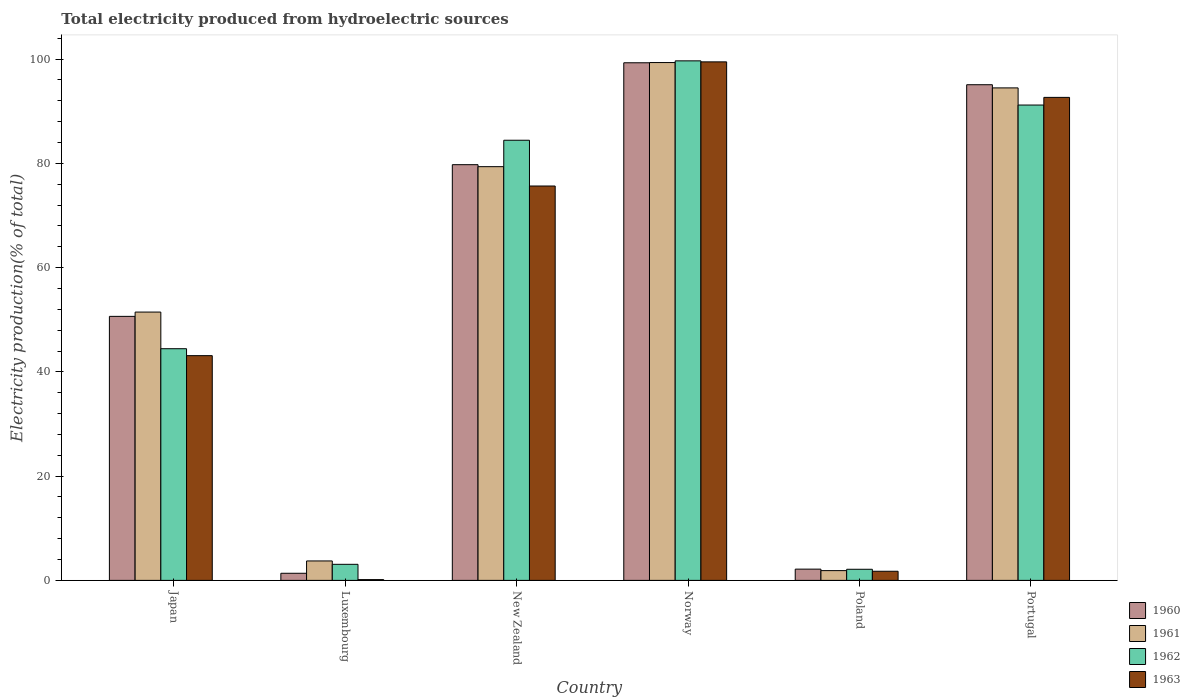How many different coloured bars are there?
Provide a succinct answer. 4. How many groups of bars are there?
Your answer should be compact. 6. Are the number of bars per tick equal to the number of legend labels?
Offer a terse response. Yes. How many bars are there on the 5th tick from the left?
Make the answer very short. 4. How many bars are there on the 4th tick from the right?
Keep it short and to the point. 4. What is the label of the 2nd group of bars from the left?
Give a very brief answer. Luxembourg. What is the total electricity produced in 1961 in New Zealand?
Your answer should be compact. 79.37. Across all countries, what is the maximum total electricity produced in 1961?
Give a very brief answer. 99.34. Across all countries, what is the minimum total electricity produced in 1962?
Provide a short and direct response. 2.13. In which country was the total electricity produced in 1960 minimum?
Your answer should be very brief. Luxembourg. What is the total total electricity produced in 1960 in the graph?
Provide a succinct answer. 328.31. What is the difference between the total electricity produced in 1962 in Luxembourg and that in Norway?
Offer a terse response. -96.59. What is the difference between the total electricity produced in 1962 in Japan and the total electricity produced in 1960 in New Zealand?
Your response must be concise. -35.31. What is the average total electricity produced in 1963 per country?
Ensure brevity in your answer.  52.13. What is the difference between the total electricity produced of/in 1963 and total electricity produced of/in 1961 in New Zealand?
Your answer should be compact. -3.71. What is the ratio of the total electricity produced in 1963 in Poland to that in Portugal?
Give a very brief answer. 0.02. Is the total electricity produced in 1961 in Japan less than that in New Zealand?
Your answer should be very brief. Yes. What is the difference between the highest and the second highest total electricity produced in 1961?
Your response must be concise. 4.86. What is the difference between the highest and the lowest total electricity produced in 1963?
Ensure brevity in your answer.  99.33. Is it the case that in every country, the sum of the total electricity produced in 1963 and total electricity produced in 1960 is greater than the sum of total electricity produced in 1961 and total electricity produced in 1962?
Give a very brief answer. No. What does the 1st bar from the left in Portugal represents?
Make the answer very short. 1960. What does the 2nd bar from the right in Norway represents?
Your response must be concise. 1962. How many bars are there?
Keep it short and to the point. 24. How many countries are there in the graph?
Ensure brevity in your answer.  6. What is the difference between two consecutive major ticks on the Y-axis?
Provide a short and direct response. 20. Does the graph contain grids?
Give a very brief answer. No. How many legend labels are there?
Keep it short and to the point. 4. What is the title of the graph?
Your response must be concise. Total electricity produced from hydroelectric sources. Does "1987" appear as one of the legend labels in the graph?
Offer a terse response. No. What is the Electricity production(% of total) in 1960 in Japan?
Your answer should be compact. 50.65. What is the Electricity production(% of total) in 1961 in Japan?
Give a very brief answer. 51.48. What is the Electricity production(% of total) in 1962 in Japan?
Your answer should be compact. 44.44. What is the Electricity production(% of total) of 1963 in Japan?
Ensure brevity in your answer.  43.11. What is the Electricity production(% of total) of 1960 in Luxembourg?
Offer a very short reply. 1.37. What is the Electricity production(% of total) in 1961 in Luxembourg?
Make the answer very short. 3.73. What is the Electricity production(% of total) in 1962 in Luxembourg?
Make the answer very short. 3.08. What is the Electricity production(% of total) of 1963 in Luxembourg?
Make the answer very short. 0.15. What is the Electricity production(% of total) in 1960 in New Zealand?
Your answer should be compact. 79.75. What is the Electricity production(% of total) of 1961 in New Zealand?
Your response must be concise. 79.37. What is the Electricity production(% of total) of 1962 in New Zealand?
Keep it short and to the point. 84.44. What is the Electricity production(% of total) in 1963 in New Zealand?
Provide a succinct answer. 75.66. What is the Electricity production(% of total) of 1960 in Norway?
Give a very brief answer. 99.3. What is the Electricity production(% of total) of 1961 in Norway?
Provide a succinct answer. 99.34. What is the Electricity production(% of total) of 1962 in Norway?
Your answer should be very brief. 99.67. What is the Electricity production(% of total) of 1963 in Norway?
Offer a terse response. 99.47. What is the Electricity production(% of total) of 1960 in Poland?
Provide a short and direct response. 2.16. What is the Electricity production(% of total) of 1961 in Poland?
Provide a succinct answer. 1.87. What is the Electricity production(% of total) of 1962 in Poland?
Your response must be concise. 2.13. What is the Electricity production(% of total) of 1963 in Poland?
Your response must be concise. 1.75. What is the Electricity production(% of total) of 1960 in Portugal?
Your answer should be compact. 95.09. What is the Electricity production(% of total) in 1961 in Portugal?
Your response must be concise. 94.48. What is the Electricity production(% of total) in 1962 in Portugal?
Your answer should be compact. 91.19. What is the Electricity production(% of total) of 1963 in Portugal?
Your answer should be very brief. 92.66. Across all countries, what is the maximum Electricity production(% of total) in 1960?
Give a very brief answer. 99.3. Across all countries, what is the maximum Electricity production(% of total) of 1961?
Make the answer very short. 99.34. Across all countries, what is the maximum Electricity production(% of total) of 1962?
Your response must be concise. 99.67. Across all countries, what is the maximum Electricity production(% of total) of 1963?
Keep it short and to the point. 99.47. Across all countries, what is the minimum Electricity production(% of total) of 1960?
Keep it short and to the point. 1.37. Across all countries, what is the minimum Electricity production(% of total) in 1961?
Provide a short and direct response. 1.87. Across all countries, what is the minimum Electricity production(% of total) of 1962?
Provide a short and direct response. 2.13. Across all countries, what is the minimum Electricity production(% of total) of 1963?
Offer a terse response. 0.15. What is the total Electricity production(% of total) of 1960 in the graph?
Provide a short and direct response. 328.31. What is the total Electricity production(% of total) of 1961 in the graph?
Ensure brevity in your answer.  330.28. What is the total Electricity production(% of total) of 1962 in the graph?
Your answer should be very brief. 324.96. What is the total Electricity production(% of total) in 1963 in the graph?
Ensure brevity in your answer.  312.81. What is the difference between the Electricity production(% of total) of 1960 in Japan and that in Luxembourg?
Your answer should be very brief. 49.28. What is the difference between the Electricity production(% of total) of 1961 in Japan and that in Luxembourg?
Your response must be concise. 47.75. What is the difference between the Electricity production(% of total) of 1962 in Japan and that in Luxembourg?
Provide a short and direct response. 41.36. What is the difference between the Electricity production(% of total) of 1963 in Japan and that in Luxembourg?
Provide a succinct answer. 42.97. What is the difference between the Electricity production(% of total) of 1960 in Japan and that in New Zealand?
Your answer should be compact. -29.1. What is the difference between the Electricity production(% of total) of 1961 in Japan and that in New Zealand?
Offer a terse response. -27.9. What is the difference between the Electricity production(% of total) of 1962 in Japan and that in New Zealand?
Make the answer very short. -39.99. What is the difference between the Electricity production(% of total) of 1963 in Japan and that in New Zealand?
Your answer should be very brief. -32.54. What is the difference between the Electricity production(% of total) of 1960 in Japan and that in Norway?
Your answer should be compact. -48.65. What is the difference between the Electricity production(% of total) of 1961 in Japan and that in Norway?
Give a very brief answer. -47.87. What is the difference between the Electricity production(% of total) of 1962 in Japan and that in Norway?
Keep it short and to the point. -55.23. What is the difference between the Electricity production(% of total) in 1963 in Japan and that in Norway?
Provide a short and direct response. -56.36. What is the difference between the Electricity production(% of total) in 1960 in Japan and that in Poland?
Offer a terse response. 48.49. What is the difference between the Electricity production(% of total) in 1961 in Japan and that in Poland?
Give a very brief answer. 49.6. What is the difference between the Electricity production(% of total) of 1962 in Japan and that in Poland?
Offer a terse response. 42.31. What is the difference between the Electricity production(% of total) of 1963 in Japan and that in Poland?
Offer a very short reply. 41.36. What is the difference between the Electricity production(% of total) in 1960 in Japan and that in Portugal?
Your answer should be compact. -44.44. What is the difference between the Electricity production(% of total) of 1961 in Japan and that in Portugal?
Make the answer very short. -43. What is the difference between the Electricity production(% of total) of 1962 in Japan and that in Portugal?
Provide a succinct answer. -46.75. What is the difference between the Electricity production(% of total) of 1963 in Japan and that in Portugal?
Ensure brevity in your answer.  -49.55. What is the difference between the Electricity production(% of total) in 1960 in Luxembourg and that in New Zealand?
Keep it short and to the point. -78.38. What is the difference between the Electricity production(% of total) of 1961 in Luxembourg and that in New Zealand?
Keep it short and to the point. -75.64. What is the difference between the Electricity production(% of total) of 1962 in Luxembourg and that in New Zealand?
Your answer should be very brief. -81.36. What is the difference between the Electricity production(% of total) in 1963 in Luxembourg and that in New Zealand?
Make the answer very short. -75.51. What is the difference between the Electricity production(% of total) in 1960 in Luxembourg and that in Norway?
Your response must be concise. -97.93. What is the difference between the Electricity production(% of total) in 1961 in Luxembourg and that in Norway?
Your response must be concise. -95.61. What is the difference between the Electricity production(% of total) of 1962 in Luxembourg and that in Norway?
Make the answer very short. -96.59. What is the difference between the Electricity production(% of total) of 1963 in Luxembourg and that in Norway?
Your answer should be compact. -99.33. What is the difference between the Electricity production(% of total) in 1960 in Luxembourg and that in Poland?
Your answer should be compact. -0.79. What is the difference between the Electricity production(% of total) in 1961 in Luxembourg and that in Poland?
Your answer should be compact. 1.86. What is the difference between the Electricity production(% of total) in 1962 in Luxembourg and that in Poland?
Keep it short and to the point. 0.95. What is the difference between the Electricity production(% of total) in 1963 in Luxembourg and that in Poland?
Your answer should be very brief. -1.6. What is the difference between the Electricity production(% of total) of 1960 in Luxembourg and that in Portugal?
Your response must be concise. -93.72. What is the difference between the Electricity production(% of total) of 1961 in Luxembourg and that in Portugal?
Offer a terse response. -90.75. What is the difference between the Electricity production(% of total) of 1962 in Luxembourg and that in Portugal?
Your answer should be very brief. -88.11. What is the difference between the Electricity production(% of total) of 1963 in Luxembourg and that in Portugal?
Your response must be concise. -92.51. What is the difference between the Electricity production(% of total) of 1960 in New Zealand and that in Norway?
Ensure brevity in your answer.  -19.55. What is the difference between the Electricity production(% of total) in 1961 in New Zealand and that in Norway?
Keep it short and to the point. -19.97. What is the difference between the Electricity production(% of total) in 1962 in New Zealand and that in Norway?
Give a very brief answer. -15.23. What is the difference between the Electricity production(% of total) in 1963 in New Zealand and that in Norway?
Provide a succinct answer. -23.82. What is the difference between the Electricity production(% of total) of 1960 in New Zealand and that in Poland?
Provide a succinct answer. 77.59. What is the difference between the Electricity production(% of total) of 1961 in New Zealand and that in Poland?
Your answer should be compact. 77.5. What is the difference between the Electricity production(% of total) of 1962 in New Zealand and that in Poland?
Provide a short and direct response. 82.31. What is the difference between the Electricity production(% of total) in 1963 in New Zealand and that in Poland?
Provide a short and direct response. 73.91. What is the difference between the Electricity production(% of total) of 1960 in New Zealand and that in Portugal?
Offer a very short reply. -15.34. What is the difference between the Electricity production(% of total) in 1961 in New Zealand and that in Portugal?
Keep it short and to the point. -15.11. What is the difference between the Electricity production(% of total) of 1962 in New Zealand and that in Portugal?
Give a very brief answer. -6.75. What is the difference between the Electricity production(% of total) in 1963 in New Zealand and that in Portugal?
Offer a terse response. -17. What is the difference between the Electricity production(% of total) in 1960 in Norway and that in Poland?
Make the answer very short. 97.14. What is the difference between the Electricity production(% of total) of 1961 in Norway and that in Poland?
Give a very brief answer. 97.47. What is the difference between the Electricity production(% of total) in 1962 in Norway and that in Poland?
Ensure brevity in your answer.  97.54. What is the difference between the Electricity production(% of total) of 1963 in Norway and that in Poland?
Provide a succinct answer. 97.72. What is the difference between the Electricity production(% of total) of 1960 in Norway and that in Portugal?
Your answer should be compact. 4.21. What is the difference between the Electricity production(% of total) of 1961 in Norway and that in Portugal?
Ensure brevity in your answer.  4.86. What is the difference between the Electricity production(% of total) in 1962 in Norway and that in Portugal?
Provide a short and direct response. 8.48. What is the difference between the Electricity production(% of total) in 1963 in Norway and that in Portugal?
Offer a very short reply. 6.81. What is the difference between the Electricity production(% of total) in 1960 in Poland and that in Portugal?
Give a very brief answer. -92.93. What is the difference between the Electricity production(% of total) in 1961 in Poland and that in Portugal?
Provide a succinct answer. -92.61. What is the difference between the Electricity production(% of total) in 1962 in Poland and that in Portugal?
Provide a succinct answer. -89.06. What is the difference between the Electricity production(% of total) of 1963 in Poland and that in Portugal?
Provide a short and direct response. -90.91. What is the difference between the Electricity production(% of total) in 1960 in Japan and the Electricity production(% of total) in 1961 in Luxembourg?
Offer a terse response. 46.92. What is the difference between the Electricity production(% of total) in 1960 in Japan and the Electricity production(% of total) in 1962 in Luxembourg?
Your answer should be very brief. 47.57. What is the difference between the Electricity production(% of total) of 1960 in Japan and the Electricity production(% of total) of 1963 in Luxembourg?
Offer a very short reply. 50.5. What is the difference between the Electricity production(% of total) in 1961 in Japan and the Electricity production(% of total) in 1962 in Luxembourg?
Ensure brevity in your answer.  48.39. What is the difference between the Electricity production(% of total) in 1961 in Japan and the Electricity production(% of total) in 1963 in Luxembourg?
Provide a succinct answer. 51.33. What is the difference between the Electricity production(% of total) in 1962 in Japan and the Electricity production(% of total) in 1963 in Luxembourg?
Provide a short and direct response. 44.3. What is the difference between the Electricity production(% of total) of 1960 in Japan and the Electricity production(% of total) of 1961 in New Zealand?
Ensure brevity in your answer.  -28.72. What is the difference between the Electricity production(% of total) of 1960 in Japan and the Electricity production(% of total) of 1962 in New Zealand?
Keep it short and to the point. -33.79. What is the difference between the Electricity production(% of total) of 1960 in Japan and the Electricity production(% of total) of 1963 in New Zealand?
Ensure brevity in your answer.  -25.01. What is the difference between the Electricity production(% of total) of 1961 in Japan and the Electricity production(% of total) of 1962 in New Zealand?
Your answer should be very brief. -32.96. What is the difference between the Electricity production(% of total) of 1961 in Japan and the Electricity production(% of total) of 1963 in New Zealand?
Offer a very short reply. -24.18. What is the difference between the Electricity production(% of total) of 1962 in Japan and the Electricity production(% of total) of 1963 in New Zealand?
Offer a very short reply. -31.21. What is the difference between the Electricity production(% of total) of 1960 in Japan and the Electricity production(% of total) of 1961 in Norway?
Your answer should be compact. -48.69. What is the difference between the Electricity production(% of total) in 1960 in Japan and the Electricity production(% of total) in 1962 in Norway?
Offer a very short reply. -49.02. What is the difference between the Electricity production(% of total) of 1960 in Japan and the Electricity production(% of total) of 1963 in Norway?
Provide a short and direct response. -48.83. What is the difference between the Electricity production(% of total) in 1961 in Japan and the Electricity production(% of total) in 1962 in Norway?
Give a very brief answer. -48.19. What is the difference between the Electricity production(% of total) of 1961 in Japan and the Electricity production(% of total) of 1963 in Norway?
Provide a succinct answer. -48. What is the difference between the Electricity production(% of total) in 1962 in Japan and the Electricity production(% of total) in 1963 in Norway?
Your response must be concise. -55.03. What is the difference between the Electricity production(% of total) of 1960 in Japan and the Electricity production(% of total) of 1961 in Poland?
Offer a terse response. 48.78. What is the difference between the Electricity production(% of total) of 1960 in Japan and the Electricity production(% of total) of 1962 in Poland?
Ensure brevity in your answer.  48.52. What is the difference between the Electricity production(% of total) of 1960 in Japan and the Electricity production(% of total) of 1963 in Poland?
Give a very brief answer. 48.9. What is the difference between the Electricity production(% of total) of 1961 in Japan and the Electricity production(% of total) of 1962 in Poland?
Provide a short and direct response. 49.34. What is the difference between the Electricity production(% of total) in 1961 in Japan and the Electricity production(% of total) in 1963 in Poland?
Provide a succinct answer. 49.72. What is the difference between the Electricity production(% of total) of 1962 in Japan and the Electricity production(% of total) of 1963 in Poland?
Give a very brief answer. 42.69. What is the difference between the Electricity production(% of total) in 1960 in Japan and the Electricity production(% of total) in 1961 in Portugal?
Give a very brief answer. -43.83. What is the difference between the Electricity production(% of total) in 1960 in Japan and the Electricity production(% of total) in 1962 in Portugal?
Provide a succinct answer. -40.54. What is the difference between the Electricity production(% of total) in 1960 in Japan and the Electricity production(% of total) in 1963 in Portugal?
Give a very brief answer. -42.01. What is the difference between the Electricity production(% of total) in 1961 in Japan and the Electricity production(% of total) in 1962 in Portugal?
Make the answer very short. -39.72. What is the difference between the Electricity production(% of total) in 1961 in Japan and the Electricity production(% of total) in 1963 in Portugal?
Your answer should be very brief. -41.18. What is the difference between the Electricity production(% of total) of 1962 in Japan and the Electricity production(% of total) of 1963 in Portugal?
Provide a short and direct response. -48.22. What is the difference between the Electricity production(% of total) in 1960 in Luxembourg and the Electricity production(% of total) in 1961 in New Zealand?
Give a very brief answer. -78.01. What is the difference between the Electricity production(% of total) of 1960 in Luxembourg and the Electricity production(% of total) of 1962 in New Zealand?
Offer a terse response. -83.07. What is the difference between the Electricity production(% of total) of 1960 in Luxembourg and the Electricity production(% of total) of 1963 in New Zealand?
Provide a succinct answer. -74.29. What is the difference between the Electricity production(% of total) in 1961 in Luxembourg and the Electricity production(% of total) in 1962 in New Zealand?
Provide a short and direct response. -80.71. What is the difference between the Electricity production(% of total) of 1961 in Luxembourg and the Electricity production(% of total) of 1963 in New Zealand?
Provide a short and direct response. -71.93. What is the difference between the Electricity production(% of total) of 1962 in Luxembourg and the Electricity production(% of total) of 1963 in New Zealand?
Your answer should be compact. -72.58. What is the difference between the Electricity production(% of total) in 1960 in Luxembourg and the Electricity production(% of total) in 1961 in Norway?
Your answer should be compact. -97.98. What is the difference between the Electricity production(% of total) of 1960 in Luxembourg and the Electricity production(% of total) of 1962 in Norway?
Make the answer very short. -98.3. What is the difference between the Electricity production(% of total) of 1960 in Luxembourg and the Electricity production(% of total) of 1963 in Norway?
Offer a terse response. -98.11. What is the difference between the Electricity production(% of total) in 1961 in Luxembourg and the Electricity production(% of total) in 1962 in Norway?
Provide a succinct answer. -95.94. What is the difference between the Electricity production(% of total) of 1961 in Luxembourg and the Electricity production(% of total) of 1963 in Norway?
Keep it short and to the point. -95.74. What is the difference between the Electricity production(% of total) of 1962 in Luxembourg and the Electricity production(% of total) of 1963 in Norway?
Provide a succinct answer. -96.39. What is the difference between the Electricity production(% of total) of 1960 in Luxembourg and the Electricity production(% of total) of 1961 in Poland?
Your response must be concise. -0.51. What is the difference between the Electricity production(% of total) of 1960 in Luxembourg and the Electricity production(% of total) of 1962 in Poland?
Offer a terse response. -0.77. What is the difference between the Electricity production(% of total) in 1960 in Luxembourg and the Electricity production(% of total) in 1963 in Poland?
Provide a succinct answer. -0.39. What is the difference between the Electricity production(% of total) of 1961 in Luxembourg and the Electricity production(% of total) of 1962 in Poland?
Offer a very short reply. 1.6. What is the difference between the Electricity production(% of total) of 1961 in Luxembourg and the Electricity production(% of total) of 1963 in Poland?
Keep it short and to the point. 1.98. What is the difference between the Electricity production(% of total) of 1962 in Luxembourg and the Electricity production(% of total) of 1963 in Poland?
Provide a short and direct response. 1.33. What is the difference between the Electricity production(% of total) of 1960 in Luxembourg and the Electricity production(% of total) of 1961 in Portugal?
Provide a short and direct response. -93.11. What is the difference between the Electricity production(% of total) of 1960 in Luxembourg and the Electricity production(% of total) of 1962 in Portugal?
Provide a short and direct response. -89.83. What is the difference between the Electricity production(% of total) in 1960 in Luxembourg and the Electricity production(% of total) in 1963 in Portugal?
Offer a very short reply. -91.29. What is the difference between the Electricity production(% of total) of 1961 in Luxembourg and the Electricity production(% of total) of 1962 in Portugal?
Your response must be concise. -87.46. What is the difference between the Electricity production(% of total) of 1961 in Luxembourg and the Electricity production(% of total) of 1963 in Portugal?
Ensure brevity in your answer.  -88.93. What is the difference between the Electricity production(% of total) in 1962 in Luxembourg and the Electricity production(% of total) in 1963 in Portugal?
Your answer should be compact. -89.58. What is the difference between the Electricity production(% of total) of 1960 in New Zealand and the Electricity production(% of total) of 1961 in Norway?
Your answer should be very brief. -19.59. What is the difference between the Electricity production(% of total) in 1960 in New Zealand and the Electricity production(% of total) in 1962 in Norway?
Give a very brief answer. -19.92. What is the difference between the Electricity production(% of total) in 1960 in New Zealand and the Electricity production(% of total) in 1963 in Norway?
Offer a terse response. -19.72. What is the difference between the Electricity production(% of total) of 1961 in New Zealand and the Electricity production(% of total) of 1962 in Norway?
Give a very brief answer. -20.3. What is the difference between the Electricity production(% of total) of 1961 in New Zealand and the Electricity production(% of total) of 1963 in Norway?
Provide a succinct answer. -20.1. What is the difference between the Electricity production(% of total) in 1962 in New Zealand and the Electricity production(% of total) in 1963 in Norway?
Provide a short and direct response. -15.04. What is the difference between the Electricity production(% of total) of 1960 in New Zealand and the Electricity production(% of total) of 1961 in Poland?
Provide a short and direct response. 77.88. What is the difference between the Electricity production(% of total) of 1960 in New Zealand and the Electricity production(% of total) of 1962 in Poland?
Give a very brief answer. 77.62. What is the difference between the Electricity production(% of total) in 1960 in New Zealand and the Electricity production(% of total) in 1963 in Poland?
Offer a terse response. 78. What is the difference between the Electricity production(% of total) of 1961 in New Zealand and the Electricity production(% of total) of 1962 in Poland?
Make the answer very short. 77.24. What is the difference between the Electricity production(% of total) of 1961 in New Zealand and the Electricity production(% of total) of 1963 in Poland?
Offer a very short reply. 77.62. What is the difference between the Electricity production(% of total) in 1962 in New Zealand and the Electricity production(% of total) in 1963 in Poland?
Your answer should be compact. 82.69. What is the difference between the Electricity production(% of total) of 1960 in New Zealand and the Electricity production(% of total) of 1961 in Portugal?
Your answer should be very brief. -14.73. What is the difference between the Electricity production(% of total) in 1960 in New Zealand and the Electricity production(% of total) in 1962 in Portugal?
Your answer should be compact. -11.44. What is the difference between the Electricity production(% of total) in 1960 in New Zealand and the Electricity production(% of total) in 1963 in Portugal?
Your response must be concise. -12.91. What is the difference between the Electricity production(% of total) of 1961 in New Zealand and the Electricity production(% of total) of 1962 in Portugal?
Provide a succinct answer. -11.82. What is the difference between the Electricity production(% of total) in 1961 in New Zealand and the Electricity production(% of total) in 1963 in Portugal?
Your response must be concise. -13.29. What is the difference between the Electricity production(% of total) of 1962 in New Zealand and the Electricity production(% of total) of 1963 in Portugal?
Keep it short and to the point. -8.22. What is the difference between the Electricity production(% of total) of 1960 in Norway and the Electricity production(% of total) of 1961 in Poland?
Your response must be concise. 97.43. What is the difference between the Electricity production(% of total) in 1960 in Norway and the Electricity production(% of total) in 1962 in Poland?
Give a very brief answer. 97.17. What is the difference between the Electricity production(% of total) of 1960 in Norway and the Electricity production(% of total) of 1963 in Poland?
Offer a terse response. 97.55. What is the difference between the Electricity production(% of total) of 1961 in Norway and the Electricity production(% of total) of 1962 in Poland?
Offer a terse response. 97.21. What is the difference between the Electricity production(% of total) in 1961 in Norway and the Electricity production(% of total) in 1963 in Poland?
Offer a terse response. 97.59. What is the difference between the Electricity production(% of total) in 1962 in Norway and the Electricity production(% of total) in 1963 in Poland?
Keep it short and to the point. 97.92. What is the difference between the Electricity production(% of total) of 1960 in Norway and the Electricity production(% of total) of 1961 in Portugal?
Keep it short and to the point. 4.82. What is the difference between the Electricity production(% of total) in 1960 in Norway and the Electricity production(% of total) in 1962 in Portugal?
Your answer should be compact. 8.11. What is the difference between the Electricity production(% of total) in 1960 in Norway and the Electricity production(% of total) in 1963 in Portugal?
Make the answer very short. 6.64. What is the difference between the Electricity production(% of total) in 1961 in Norway and the Electricity production(% of total) in 1962 in Portugal?
Offer a terse response. 8.15. What is the difference between the Electricity production(% of total) in 1961 in Norway and the Electricity production(% of total) in 1963 in Portugal?
Give a very brief answer. 6.68. What is the difference between the Electricity production(% of total) of 1962 in Norway and the Electricity production(% of total) of 1963 in Portugal?
Offer a very short reply. 7.01. What is the difference between the Electricity production(% of total) of 1960 in Poland and the Electricity production(% of total) of 1961 in Portugal?
Your response must be concise. -92.32. What is the difference between the Electricity production(% of total) in 1960 in Poland and the Electricity production(% of total) in 1962 in Portugal?
Keep it short and to the point. -89.03. What is the difference between the Electricity production(% of total) of 1960 in Poland and the Electricity production(% of total) of 1963 in Portugal?
Provide a short and direct response. -90.5. What is the difference between the Electricity production(% of total) of 1961 in Poland and the Electricity production(% of total) of 1962 in Portugal?
Give a very brief answer. -89.32. What is the difference between the Electricity production(% of total) in 1961 in Poland and the Electricity production(% of total) in 1963 in Portugal?
Your answer should be compact. -90.79. What is the difference between the Electricity production(% of total) in 1962 in Poland and the Electricity production(% of total) in 1963 in Portugal?
Make the answer very short. -90.53. What is the average Electricity production(% of total) in 1960 per country?
Your response must be concise. 54.72. What is the average Electricity production(% of total) of 1961 per country?
Make the answer very short. 55.05. What is the average Electricity production(% of total) in 1962 per country?
Give a very brief answer. 54.16. What is the average Electricity production(% of total) of 1963 per country?
Your answer should be compact. 52.13. What is the difference between the Electricity production(% of total) in 1960 and Electricity production(% of total) in 1961 in Japan?
Provide a succinct answer. -0.83. What is the difference between the Electricity production(% of total) in 1960 and Electricity production(% of total) in 1962 in Japan?
Your response must be concise. 6.2. What is the difference between the Electricity production(% of total) of 1960 and Electricity production(% of total) of 1963 in Japan?
Make the answer very short. 7.54. What is the difference between the Electricity production(% of total) in 1961 and Electricity production(% of total) in 1962 in Japan?
Give a very brief answer. 7.03. What is the difference between the Electricity production(% of total) in 1961 and Electricity production(% of total) in 1963 in Japan?
Give a very brief answer. 8.36. What is the difference between the Electricity production(% of total) of 1962 and Electricity production(% of total) of 1963 in Japan?
Offer a terse response. 1.33. What is the difference between the Electricity production(% of total) in 1960 and Electricity production(% of total) in 1961 in Luxembourg?
Offer a very short reply. -2.36. What is the difference between the Electricity production(% of total) of 1960 and Electricity production(% of total) of 1962 in Luxembourg?
Your response must be concise. -1.72. What is the difference between the Electricity production(% of total) in 1960 and Electricity production(% of total) in 1963 in Luxembourg?
Offer a terse response. 1.22. What is the difference between the Electricity production(% of total) in 1961 and Electricity production(% of total) in 1962 in Luxembourg?
Make the answer very short. 0.65. What is the difference between the Electricity production(% of total) in 1961 and Electricity production(% of total) in 1963 in Luxembourg?
Ensure brevity in your answer.  3.58. What is the difference between the Electricity production(% of total) of 1962 and Electricity production(% of total) of 1963 in Luxembourg?
Make the answer very short. 2.93. What is the difference between the Electricity production(% of total) of 1960 and Electricity production(% of total) of 1961 in New Zealand?
Provide a succinct answer. 0.38. What is the difference between the Electricity production(% of total) in 1960 and Electricity production(% of total) in 1962 in New Zealand?
Your answer should be very brief. -4.69. What is the difference between the Electricity production(% of total) in 1960 and Electricity production(% of total) in 1963 in New Zealand?
Make the answer very short. 4.09. What is the difference between the Electricity production(% of total) of 1961 and Electricity production(% of total) of 1962 in New Zealand?
Offer a terse response. -5.07. What is the difference between the Electricity production(% of total) of 1961 and Electricity production(% of total) of 1963 in New Zealand?
Provide a succinct answer. 3.71. What is the difference between the Electricity production(% of total) of 1962 and Electricity production(% of total) of 1963 in New Zealand?
Make the answer very short. 8.78. What is the difference between the Electricity production(% of total) of 1960 and Electricity production(% of total) of 1961 in Norway?
Make the answer very short. -0.04. What is the difference between the Electricity production(% of total) in 1960 and Electricity production(% of total) in 1962 in Norway?
Provide a short and direct response. -0.37. What is the difference between the Electricity production(% of total) of 1960 and Electricity production(% of total) of 1963 in Norway?
Your answer should be very brief. -0.17. What is the difference between the Electricity production(% of total) of 1961 and Electricity production(% of total) of 1962 in Norway?
Your response must be concise. -0.33. What is the difference between the Electricity production(% of total) in 1961 and Electricity production(% of total) in 1963 in Norway?
Give a very brief answer. -0.13. What is the difference between the Electricity production(% of total) of 1962 and Electricity production(% of total) of 1963 in Norway?
Make the answer very short. 0.19. What is the difference between the Electricity production(% of total) of 1960 and Electricity production(% of total) of 1961 in Poland?
Make the answer very short. 0.28. What is the difference between the Electricity production(% of total) of 1960 and Electricity production(% of total) of 1962 in Poland?
Offer a very short reply. 0.03. What is the difference between the Electricity production(% of total) of 1960 and Electricity production(% of total) of 1963 in Poland?
Provide a short and direct response. 0.41. What is the difference between the Electricity production(% of total) of 1961 and Electricity production(% of total) of 1962 in Poland?
Keep it short and to the point. -0.26. What is the difference between the Electricity production(% of total) in 1961 and Electricity production(% of total) in 1963 in Poland?
Your answer should be very brief. 0.12. What is the difference between the Electricity production(% of total) of 1962 and Electricity production(% of total) of 1963 in Poland?
Offer a very short reply. 0.38. What is the difference between the Electricity production(% of total) in 1960 and Electricity production(% of total) in 1961 in Portugal?
Offer a terse response. 0.61. What is the difference between the Electricity production(% of total) in 1960 and Electricity production(% of total) in 1962 in Portugal?
Provide a short and direct response. 3.9. What is the difference between the Electricity production(% of total) in 1960 and Electricity production(% of total) in 1963 in Portugal?
Give a very brief answer. 2.43. What is the difference between the Electricity production(% of total) of 1961 and Electricity production(% of total) of 1962 in Portugal?
Give a very brief answer. 3.29. What is the difference between the Electricity production(% of total) in 1961 and Electricity production(% of total) in 1963 in Portugal?
Provide a short and direct response. 1.82. What is the difference between the Electricity production(% of total) of 1962 and Electricity production(% of total) of 1963 in Portugal?
Keep it short and to the point. -1.47. What is the ratio of the Electricity production(% of total) of 1960 in Japan to that in Luxembourg?
Provide a succinct answer. 37.08. What is the ratio of the Electricity production(% of total) in 1961 in Japan to that in Luxembourg?
Offer a terse response. 13.8. What is the ratio of the Electricity production(% of total) of 1962 in Japan to that in Luxembourg?
Give a very brief answer. 14.42. What is the ratio of the Electricity production(% of total) in 1963 in Japan to that in Luxembourg?
Your response must be concise. 292.1. What is the ratio of the Electricity production(% of total) in 1960 in Japan to that in New Zealand?
Your answer should be compact. 0.64. What is the ratio of the Electricity production(% of total) in 1961 in Japan to that in New Zealand?
Your response must be concise. 0.65. What is the ratio of the Electricity production(% of total) of 1962 in Japan to that in New Zealand?
Keep it short and to the point. 0.53. What is the ratio of the Electricity production(% of total) of 1963 in Japan to that in New Zealand?
Keep it short and to the point. 0.57. What is the ratio of the Electricity production(% of total) in 1960 in Japan to that in Norway?
Your response must be concise. 0.51. What is the ratio of the Electricity production(% of total) of 1961 in Japan to that in Norway?
Offer a terse response. 0.52. What is the ratio of the Electricity production(% of total) of 1962 in Japan to that in Norway?
Make the answer very short. 0.45. What is the ratio of the Electricity production(% of total) in 1963 in Japan to that in Norway?
Your answer should be compact. 0.43. What is the ratio of the Electricity production(% of total) in 1960 in Japan to that in Poland?
Keep it short and to the point. 23.47. What is the ratio of the Electricity production(% of total) in 1961 in Japan to that in Poland?
Make the answer very short. 27.48. What is the ratio of the Electricity production(% of total) in 1962 in Japan to that in Poland?
Your response must be concise. 20.85. What is the ratio of the Electricity production(% of total) in 1963 in Japan to that in Poland?
Provide a short and direct response. 24.62. What is the ratio of the Electricity production(% of total) in 1960 in Japan to that in Portugal?
Your answer should be compact. 0.53. What is the ratio of the Electricity production(% of total) in 1961 in Japan to that in Portugal?
Give a very brief answer. 0.54. What is the ratio of the Electricity production(% of total) in 1962 in Japan to that in Portugal?
Provide a short and direct response. 0.49. What is the ratio of the Electricity production(% of total) of 1963 in Japan to that in Portugal?
Ensure brevity in your answer.  0.47. What is the ratio of the Electricity production(% of total) of 1960 in Luxembourg to that in New Zealand?
Offer a terse response. 0.02. What is the ratio of the Electricity production(% of total) in 1961 in Luxembourg to that in New Zealand?
Your answer should be very brief. 0.05. What is the ratio of the Electricity production(% of total) in 1962 in Luxembourg to that in New Zealand?
Offer a terse response. 0.04. What is the ratio of the Electricity production(% of total) of 1963 in Luxembourg to that in New Zealand?
Your answer should be very brief. 0. What is the ratio of the Electricity production(% of total) in 1960 in Luxembourg to that in Norway?
Offer a very short reply. 0.01. What is the ratio of the Electricity production(% of total) in 1961 in Luxembourg to that in Norway?
Provide a short and direct response. 0.04. What is the ratio of the Electricity production(% of total) of 1962 in Luxembourg to that in Norway?
Your response must be concise. 0.03. What is the ratio of the Electricity production(% of total) in 1963 in Luxembourg to that in Norway?
Offer a very short reply. 0. What is the ratio of the Electricity production(% of total) in 1960 in Luxembourg to that in Poland?
Your answer should be very brief. 0.63. What is the ratio of the Electricity production(% of total) in 1961 in Luxembourg to that in Poland?
Your answer should be very brief. 1.99. What is the ratio of the Electricity production(% of total) in 1962 in Luxembourg to that in Poland?
Offer a terse response. 1.45. What is the ratio of the Electricity production(% of total) in 1963 in Luxembourg to that in Poland?
Offer a very short reply. 0.08. What is the ratio of the Electricity production(% of total) in 1960 in Luxembourg to that in Portugal?
Your answer should be compact. 0.01. What is the ratio of the Electricity production(% of total) in 1961 in Luxembourg to that in Portugal?
Offer a very short reply. 0.04. What is the ratio of the Electricity production(% of total) of 1962 in Luxembourg to that in Portugal?
Your answer should be compact. 0.03. What is the ratio of the Electricity production(% of total) of 1963 in Luxembourg to that in Portugal?
Your response must be concise. 0. What is the ratio of the Electricity production(% of total) in 1960 in New Zealand to that in Norway?
Ensure brevity in your answer.  0.8. What is the ratio of the Electricity production(% of total) in 1961 in New Zealand to that in Norway?
Offer a very short reply. 0.8. What is the ratio of the Electricity production(% of total) of 1962 in New Zealand to that in Norway?
Give a very brief answer. 0.85. What is the ratio of the Electricity production(% of total) of 1963 in New Zealand to that in Norway?
Ensure brevity in your answer.  0.76. What is the ratio of the Electricity production(% of total) of 1960 in New Zealand to that in Poland?
Offer a terse response. 36.95. What is the ratio of the Electricity production(% of total) in 1961 in New Zealand to that in Poland?
Provide a short and direct response. 42.37. What is the ratio of the Electricity production(% of total) in 1962 in New Zealand to that in Poland?
Your response must be concise. 39.6. What is the ratio of the Electricity production(% of total) of 1963 in New Zealand to that in Poland?
Offer a very short reply. 43.2. What is the ratio of the Electricity production(% of total) in 1960 in New Zealand to that in Portugal?
Provide a short and direct response. 0.84. What is the ratio of the Electricity production(% of total) of 1961 in New Zealand to that in Portugal?
Your response must be concise. 0.84. What is the ratio of the Electricity production(% of total) of 1962 in New Zealand to that in Portugal?
Provide a succinct answer. 0.93. What is the ratio of the Electricity production(% of total) in 1963 in New Zealand to that in Portugal?
Your answer should be compact. 0.82. What is the ratio of the Electricity production(% of total) in 1960 in Norway to that in Poland?
Keep it short and to the point. 46.01. What is the ratio of the Electricity production(% of total) in 1961 in Norway to that in Poland?
Provide a short and direct response. 53.03. What is the ratio of the Electricity production(% of total) in 1962 in Norway to that in Poland?
Your answer should be very brief. 46.75. What is the ratio of the Electricity production(% of total) of 1963 in Norway to that in Poland?
Your answer should be compact. 56.8. What is the ratio of the Electricity production(% of total) in 1960 in Norway to that in Portugal?
Your answer should be very brief. 1.04. What is the ratio of the Electricity production(% of total) in 1961 in Norway to that in Portugal?
Ensure brevity in your answer.  1.05. What is the ratio of the Electricity production(% of total) in 1962 in Norway to that in Portugal?
Keep it short and to the point. 1.09. What is the ratio of the Electricity production(% of total) in 1963 in Norway to that in Portugal?
Give a very brief answer. 1.07. What is the ratio of the Electricity production(% of total) of 1960 in Poland to that in Portugal?
Provide a short and direct response. 0.02. What is the ratio of the Electricity production(% of total) of 1961 in Poland to that in Portugal?
Your answer should be very brief. 0.02. What is the ratio of the Electricity production(% of total) of 1962 in Poland to that in Portugal?
Keep it short and to the point. 0.02. What is the ratio of the Electricity production(% of total) of 1963 in Poland to that in Portugal?
Your answer should be compact. 0.02. What is the difference between the highest and the second highest Electricity production(% of total) of 1960?
Provide a succinct answer. 4.21. What is the difference between the highest and the second highest Electricity production(% of total) of 1961?
Make the answer very short. 4.86. What is the difference between the highest and the second highest Electricity production(% of total) of 1962?
Give a very brief answer. 8.48. What is the difference between the highest and the second highest Electricity production(% of total) of 1963?
Your answer should be very brief. 6.81. What is the difference between the highest and the lowest Electricity production(% of total) in 1960?
Your answer should be very brief. 97.93. What is the difference between the highest and the lowest Electricity production(% of total) in 1961?
Offer a very short reply. 97.47. What is the difference between the highest and the lowest Electricity production(% of total) in 1962?
Offer a terse response. 97.54. What is the difference between the highest and the lowest Electricity production(% of total) of 1963?
Give a very brief answer. 99.33. 